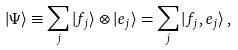Convert formula to latex. <formula><loc_0><loc_0><loc_500><loc_500>| \Psi \rangle \equiv \sum _ { j } | f _ { j } \rangle \otimes | e _ { j } \rangle = \sum _ { j } | f _ { j } , e _ { j } \rangle \, ,</formula> 